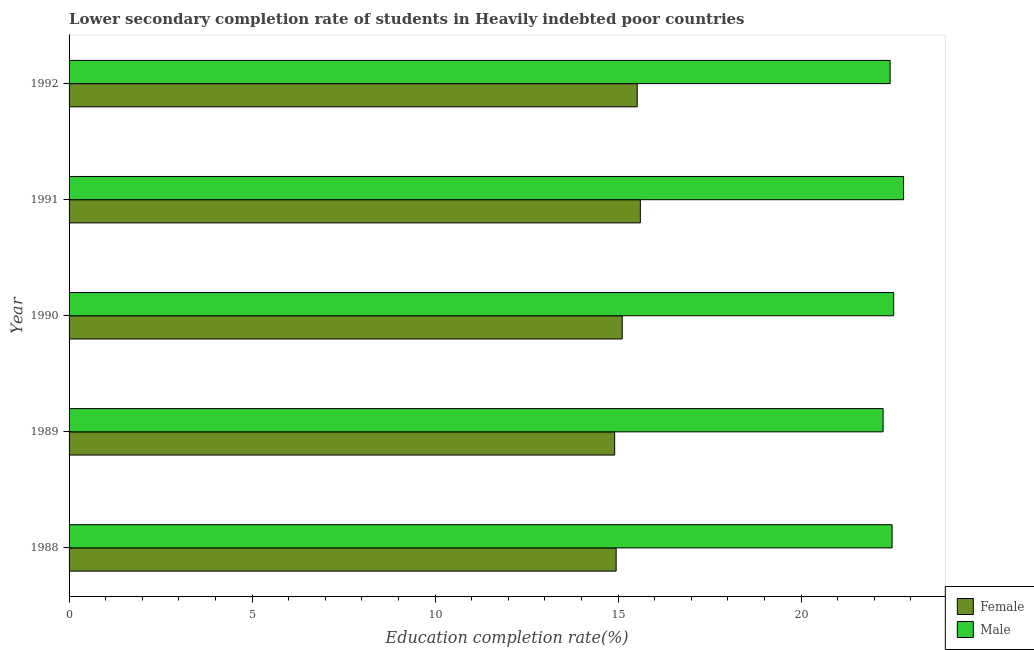Are the number of bars on each tick of the Y-axis equal?
Provide a succinct answer. Yes. How many bars are there on the 5th tick from the top?
Provide a short and direct response. 2. What is the label of the 3rd group of bars from the top?
Make the answer very short. 1990. In how many cases, is the number of bars for a given year not equal to the number of legend labels?
Offer a very short reply. 0. What is the education completion rate of female students in 1988?
Provide a short and direct response. 14.95. Across all years, what is the maximum education completion rate of female students?
Offer a terse response. 15.61. Across all years, what is the minimum education completion rate of male students?
Ensure brevity in your answer.  22.24. In which year was the education completion rate of female students maximum?
Provide a succinct answer. 1991. What is the total education completion rate of female students in the graph?
Your answer should be compact. 76.11. What is the difference between the education completion rate of male students in 1988 and that in 1990?
Ensure brevity in your answer.  -0.04. What is the difference between the education completion rate of male students in 1992 and the education completion rate of female students in 1991?
Offer a very short reply. 6.83. What is the average education completion rate of male students per year?
Provide a short and direct response. 22.5. In the year 1988, what is the difference between the education completion rate of female students and education completion rate of male students?
Your answer should be very brief. -7.54. In how many years, is the education completion rate of female students greater than 19 %?
Ensure brevity in your answer.  0. What is the ratio of the education completion rate of male students in 1989 to that in 1992?
Ensure brevity in your answer.  0.99. Is the education completion rate of female students in 1988 less than that in 1992?
Offer a terse response. Yes. What is the difference between the highest and the second highest education completion rate of male students?
Offer a terse response. 0.27. What is the difference between the highest and the lowest education completion rate of female students?
Keep it short and to the point. 0.7. What does the 1st bar from the top in 1991 represents?
Your answer should be very brief. Male. What does the 2nd bar from the bottom in 1990 represents?
Your answer should be compact. Male. How many years are there in the graph?
Offer a terse response. 5. What is the difference between two consecutive major ticks on the X-axis?
Make the answer very short. 5. Are the values on the major ticks of X-axis written in scientific E-notation?
Provide a short and direct response. No. Does the graph contain any zero values?
Ensure brevity in your answer.  No. Where does the legend appear in the graph?
Your answer should be very brief. Bottom right. How many legend labels are there?
Make the answer very short. 2. What is the title of the graph?
Offer a terse response. Lower secondary completion rate of students in Heavily indebted poor countries. Does "Gasoline" appear as one of the legend labels in the graph?
Offer a terse response. No. What is the label or title of the X-axis?
Your answer should be compact. Education completion rate(%). What is the Education completion rate(%) in Female in 1988?
Offer a terse response. 14.95. What is the Education completion rate(%) of Male in 1988?
Your response must be concise. 22.49. What is the Education completion rate(%) of Female in 1989?
Give a very brief answer. 14.91. What is the Education completion rate(%) of Male in 1989?
Keep it short and to the point. 22.24. What is the Education completion rate(%) of Female in 1990?
Keep it short and to the point. 15.11. What is the Education completion rate(%) of Male in 1990?
Your answer should be compact. 22.53. What is the Education completion rate(%) in Female in 1991?
Keep it short and to the point. 15.61. What is the Education completion rate(%) of Male in 1991?
Offer a terse response. 22.8. What is the Education completion rate(%) in Female in 1992?
Offer a very short reply. 15.52. What is the Education completion rate(%) in Male in 1992?
Offer a very short reply. 22.44. Across all years, what is the maximum Education completion rate(%) in Female?
Your answer should be compact. 15.61. Across all years, what is the maximum Education completion rate(%) in Male?
Offer a very short reply. 22.8. Across all years, what is the minimum Education completion rate(%) of Female?
Offer a very short reply. 14.91. Across all years, what is the minimum Education completion rate(%) of Male?
Give a very brief answer. 22.24. What is the total Education completion rate(%) of Female in the graph?
Keep it short and to the point. 76.11. What is the total Education completion rate(%) of Male in the graph?
Your response must be concise. 112.5. What is the difference between the Education completion rate(%) of Female in 1988 and that in 1989?
Give a very brief answer. 0.04. What is the difference between the Education completion rate(%) in Male in 1988 and that in 1989?
Offer a terse response. 0.25. What is the difference between the Education completion rate(%) in Female in 1988 and that in 1990?
Your answer should be very brief. -0.17. What is the difference between the Education completion rate(%) of Male in 1988 and that in 1990?
Give a very brief answer. -0.04. What is the difference between the Education completion rate(%) in Female in 1988 and that in 1991?
Your answer should be compact. -0.66. What is the difference between the Education completion rate(%) in Male in 1988 and that in 1991?
Provide a short and direct response. -0.31. What is the difference between the Education completion rate(%) in Female in 1988 and that in 1992?
Your answer should be compact. -0.58. What is the difference between the Education completion rate(%) in Male in 1988 and that in 1992?
Offer a terse response. 0.05. What is the difference between the Education completion rate(%) in Female in 1989 and that in 1990?
Offer a very short reply. -0.21. What is the difference between the Education completion rate(%) in Male in 1989 and that in 1990?
Your response must be concise. -0.29. What is the difference between the Education completion rate(%) of Female in 1989 and that in 1991?
Your answer should be very brief. -0.7. What is the difference between the Education completion rate(%) in Male in 1989 and that in 1991?
Ensure brevity in your answer.  -0.56. What is the difference between the Education completion rate(%) of Female in 1989 and that in 1992?
Ensure brevity in your answer.  -0.62. What is the difference between the Education completion rate(%) of Male in 1989 and that in 1992?
Offer a terse response. -0.19. What is the difference between the Education completion rate(%) in Female in 1990 and that in 1991?
Provide a short and direct response. -0.5. What is the difference between the Education completion rate(%) in Male in 1990 and that in 1991?
Make the answer very short. -0.27. What is the difference between the Education completion rate(%) of Female in 1990 and that in 1992?
Provide a short and direct response. -0.41. What is the difference between the Education completion rate(%) of Male in 1990 and that in 1992?
Provide a succinct answer. 0.1. What is the difference between the Education completion rate(%) of Female in 1991 and that in 1992?
Give a very brief answer. 0.09. What is the difference between the Education completion rate(%) of Male in 1991 and that in 1992?
Your answer should be compact. 0.37. What is the difference between the Education completion rate(%) of Female in 1988 and the Education completion rate(%) of Male in 1989?
Your answer should be compact. -7.29. What is the difference between the Education completion rate(%) of Female in 1988 and the Education completion rate(%) of Male in 1990?
Offer a very short reply. -7.58. What is the difference between the Education completion rate(%) in Female in 1988 and the Education completion rate(%) in Male in 1991?
Your answer should be very brief. -7.85. What is the difference between the Education completion rate(%) in Female in 1988 and the Education completion rate(%) in Male in 1992?
Your response must be concise. -7.49. What is the difference between the Education completion rate(%) of Female in 1989 and the Education completion rate(%) of Male in 1990?
Ensure brevity in your answer.  -7.62. What is the difference between the Education completion rate(%) in Female in 1989 and the Education completion rate(%) in Male in 1991?
Your answer should be very brief. -7.89. What is the difference between the Education completion rate(%) in Female in 1989 and the Education completion rate(%) in Male in 1992?
Your response must be concise. -7.53. What is the difference between the Education completion rate(%) of Female in 1990 and the Education completion rate(%) of Male in 1991?
Ensure brevity in your answer.  -7.69. What is the difference between the Education completion rate(%) of Female in 1990 and the Education completion rate(%) of Male in 1992?
Offer a very short reply. -7.32. What is the difference between the Education completion rate(%) of Female in 1991 and the Education completion rate(%) of Male in 1992?
Keep it short and to the point. -6.83. What is the average Education completion rate(%) of Female per year?
Your answer should be very brief. 15.22. What is the average Education completion rate(%) of Male per year?
Give a very brief answer. 22.5. In the year 1988, what is the difference between the Education completion rate(%) in Female and Education completion rate(%) in Male?
Offer a terse response. -7.54. In the year 1989, what is the difference between the Education completion rate(%) in Female and Education completion rate(%) in Male?
Your answer should be compact. -7.34. In the year 1990, what is the difference between the Education completion rate(%) in Female and Education completion rate(%) in Male?
Your response must be concise. -7.42. In the year 1991, what is the difference between the Education completion rate(%) in Female and Education completion rate(%) in Male?
Provide a short and direct response. -7.19. In the year 1992, what is the difference between the Education completion rate(%) in Female and Education completion rate(%) in Male?
Your answer should be very brief. -6.91. What is the ratio of the Education completion rate(%) of Male in 1988 to that in 1989?
Give a very brief answer. 1.01. What is the ratio of the Education completion rate(%) in Female in 1988 to that in 1991?
Provide a succinct answer. 0.96. What is the ratio of the Education completion rate(%) of Male in 1988 to that in 1991?
Provide a short and direct response. 0.99. What is the ratio of the Education completion rate(%) in Female in 1988 to that in 1992?
Your response must be concise. 0.96. What is the ratio of the Education completion rate(%) in Male in 1988 to that in 1992?
Your response must be concise. 1. What is the ratio of the Education completion rate(%) in Female in 1989 to that in 1990?
Provide a succinct answer. 0.99. What is the ratio of the Education completion rate(%) in Male in 1989 to that in 1990?
Your answer should be very brief. 0.99. What is the ratio of the Education completion rate(%) in Female in 1989 to that in 1991?
Make the answer very short. 0.96. What is the ratio of the Education completion rate(%) in Male in 1989 to that in 1991?
Ensure brevity in your answer.  0.98. What is the ratio of the Education completion rate(%) of Female in 1989 to that in 1992?
Provide a succinct answer. 0.96. What is the ratio of the Education completion rate(%) in Male in 1989 to that in 1992?
Your response must be concise. 0.99. What is the ratio of the Education completion rate(%) in Female in 1990 to that in 1991?
Ensure brevity in your answer.  0.97. What is the ratio of the Education completion rate(%) of Male in 1990 to that in 1991?
Your response must be concise. 0.99. What is the ratio of the Education completion rate(%) in Female in 1990 to that in 1992?
Give a very brief answer. 0.97. What is the ratio of the Education completion rate(%) in Female in 1991 to that in 1992?
Offer a very short reply. 1.01. What is the ratio of the Education completion rate(%) of Male in 1991 to that in 1992?
Your answer should be very brief. 1.02. What is the difference between the highest and the second highest Education completion rate(%) in Female?
Offer a terse response. 0.09. What is the difference between the highest and the second highest Education completion rate(%) in Male?
Give a very brief answer. 0.27. What is the difference between the highest and the lowest Education completion rate(%) of Female?
Provide a short and direct response. 0.7. What is the difference between the highest and the lowest Education completion rate(%) in Male?
Your answer should be very brief. 0.56. 